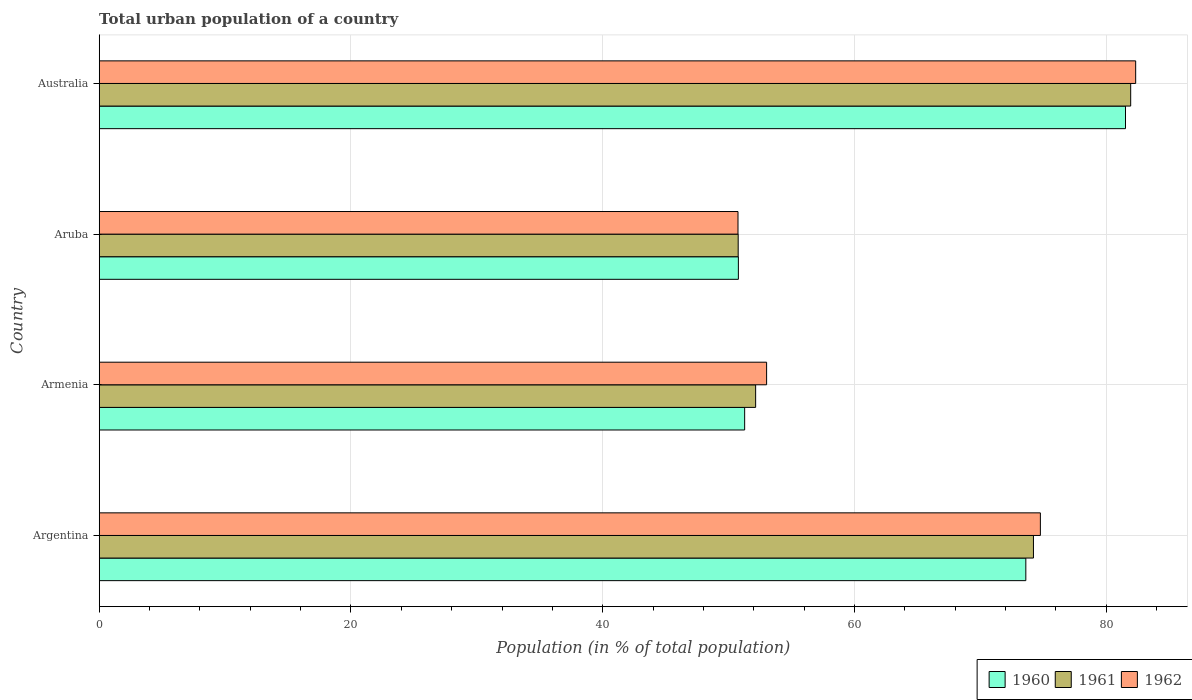Are the number of bars per tick equal to the number of legend labels?
Your response must be concise. Yes. Are the number of bars on each tick of the Y-axis equal?
Your answer should be compact. Yes. How many bars are there on the 2nd tick from the bottom?
Your answer should be very brief. 3. What is the urban population in 1962 in Aruba?
Give a very brief answer. 50.75. Across all countries, what is the maximum urban population in 1962?
Provide a short and direct response. 82.34. Across all countries, what is the minimum urban population in 1962?
Make the answer very short. 50.75. In which country was the urban population in 1962 minimum?
Keep it short and to the point. Aruba. What is the total urban population in 1962 in the graph?
Your answer should be compact. 260.87. What is the difference between the urban population in 1960 in Armenia and that in Australia?
Provide a short and direct response. -30.25. What is the difference between the urban population in 1960 in Argentina and the urban population in 1961 in Australia?
Ensure brevity in your answer.  -8.33. What is the average urban population in 1962 per country?
Your response must be concise. 65.22. What is the difference between the urban population in 1960 and urban population in 1962 in Australia?
Offer a very short reply. -0.81. What is the ratio of the urban population in 1962 in Argentina to that in Australia?
Your answer should be compact. 0.91. Is the difference between the urban population in 1960 in Argentina and Australia greater than the difference between the urban population in 1962 in Argentina and Australia?
Your response must be concise. No. What is the difference between the highest and the second highest urban population in 1961?
Offer a very short reply. 7.72. What is the difference between the highest and the lowest urban population in 1960?
Your response must be concise. 30.75. Is the sum of the urban population in 1961 in Armenia and Aruba greater than the maximum urban population in 1962 across all countries?
Keep it short and to the point. Yes. How many bars are there?
Provide a succinct answer. 12. Does the graph contain grids?
Provide a short and direct response. Yes. Where does the legend appear in the graph?
Give a very brief answer. Bottom right. How many legend labels are there?
Ensure brevity in your answer.  3. What is the title of the graph?
Keep it short and to the point. Total urban population of a country. Does "1992" appear as one of the legend labels in the graph?
Make the answer very short. No. What is the label or title of the X-axis?
Provide a succinct answer. Population (in % of total population). What is the label or title of the Y-axis?
Your response must be concise. Country. What is the Population (in % of total population) in 1960 in Argentina?
Provide a short and direct response. 73.61. What is the Population (in % of total population) in 1961 in Argentina?
Your answer should be very brief. 74.22. What is the Population (in % of total population) in 1962 in Argentina?
Your answer should be very brief. 74.77. What is the Population (in % of total population) in 1960 in Armenia?
Your answer should be very brief. 51.27. What is the Population (in % of total population) in 1961 in Armenia?
Make the answer very short. 52.15. What is the Population (in % of total population) of 1962 in Armenia?
Offer a very short reply. 53.02. What is the Population (in % of total population) of 1960 in Aruba?
Offer a terse response. 50.78. What is the Population (in % of total population) in 1961 in Aruba?
Make the answer very short. 50.76. What is the Population (in % of total population) in 1962 in Aruba?
Make the answer very short. 50.75. What is the Population (in % of total population) in 1960 in Australia?
Your answer should be very brief. 81.53. What is the Population (in % of total population) of 1961 in Australia?
Your response must be concise. 81.94. What is the Population (in % of total population) of 1962 in Australia?
Make the answer very short. 82.34. Across all countries, what is the maximum Population (in % of total population) of 1960?
Your answer should be compact. 81.53. Across all countries, what is the maximum Population (in % of total population) in 1961?
Offer a terse response. 81.94. Across all countries, what is the maximum Population (in % of total population) in 1962?
Provide a short and direct response. 82.34. Across all countries, what is the minimum Population (in % of total population) in 1960?
Give a very brief answer. 50.78. Across all countries, what is the minimum Population (in % of total population) in 1961?
Make the answer very short. 50.76. Across all countries, what is the minimum Population (in % of total population) in 1962?
Your answer should be very brief. 50.75. What is the total Population (in % of total population) in 1960 in the graph?
Provide a short and direct response. 257.19. What is the total Population (in % of total population) of 1961 in the graph?
Provide a succinct answer. 259.07. What is the total Population (in % of total population) in 1962 in the graph?
Give a very brief answer. 260.87. What is the difference between the Population (in % of total population) of 1960 in Argentina and that in Armenia?
Offer a terse response. 22.34. What is the difference between the Population (in % of total population) of 1961 in Argentina and that in Armenia?
Ensure brevity in your answer.  22.07. What is the difference between the Population (in % of total population) in 1962 in Argentina and that in Armenia?
Your response must be concise. 21.75. What is the difference between the Population (in % of total population) of 1960 in Argentina and that in Aruba?
Offer a terse response. 22.84. What is the difference between the Population (in % of total population) of 1961 in Argentina and that in Aruba?
Ensure brevity in your answer.  23.46. What is the difference between the Population (in % of total population) in 1962 in Argentina and that in Aruba?
Provide a succinct answer. 24.02. What is the difference between the Population (in % of total population) of 1960 in Argentina and that in Australia?
Offer a terse response. -7.92. What is the difference between the Population (in % of total population) in 1961 in Argentina and that in Australia?
Your response must be concise. -7.72. What is the difference between the Population (in % of total population) of 1962 in Argentina and that in Australia?
Provide a short and direct response. -7.57. What is the difference between the Population (in % of total population) of 1960 in Armenia and that in Aruba?
Your answer should be compact. 0.5. What is the difference between the Population (in % of total population) of 1961 in Armenia and that in Aruba?
Provide a succinct answer. 1.39. What is the difference between the Population (in % of total population) of 1962 in Armenia and that in Aruba?
Offer a terse response. 2.27. What is the difference between the Population (in % of total population) in 1960 in Armenia and that in Australia?
Your answer should be very brief. -30.25. What is the difference between the Population (in % of total population) of 1961 in Armenia and that in Australia?
Keep it short and to the point. -29.79. What is the difference between the Population (in % of total population) of 1962 in Armenia and that in Australia?
Provide a short and direct response. -29.32. What is the difference between the Population (in % of total population) in 1960 in Aruba and that in Australia?
Offer a very short reply. -30.75. What is the difference between the Population (in % of total population) in 1961 in Aruba and that in Australia?
Your response must be concise. -31.18. What is the difference between the Population (in % of total population) of 1962 in Aruba and that in Australia?
Your response must be concise. -31.59. What is the difference between the Population (in % of total population) of 1960 in Argentina and the Population (in % of total population) of 1961 in Armenia?
Your response must be concise. 21.46. What is the difference between the Population (in % of total population) of 1960 in Argentina and the Population (in % of total population) of 1962 in Armenia?
Ensure brevity in your answer.  20.59. What is the difference between the Population (in % of total population) of 1961 in Argentina and the Population (in % of total population) of 1962 in Armenia?
Give a very brief answer. 21.2. What is the difference between the Population (in % of total population) of 1960 in Argentina and the Population (in % of total population) of 1961 in Aruba?
Keep it short and to the point. 22.85. What is the difference between the Population (in % of total population) in 1960 in Argentina and the Population (in % of total population) in 1962 in Aruba?
Provide a succinct answer. 22.86. What is the difference between the Population (in % of total population) in 1961 in Argentina and the Population (in % of total population) in 1962 in Aruba?
Your answer should be compact. 23.47. What is the difference between the Population (in % of total population) of 1960 in Argentina and the Population (in % of total population) of 1961 in Australia?
Ensure brevity in your answer.  -8.33. What is the difference between the Population (in % of total population) in 1960 in Argentina and the Population (in % of total population) in 1962 in Australia?
Keep it short and to the point. -8.73. What is the difference between the Population (in % of total population) of 1961 in Argentina and the Population (in % of total population) of 1962 in Australia?
Make the answer very short. -8.12. What is the difference between the Population (in % of total population) of 1960 in Armenia and the Population (in % of total population) of 1961 in Aruba?
Offer a very short reply. 0.51. What is the difference between the Population (in % of total population) in 1960 in Armenia and the Population (in % of total population) in 1962 in Aruba?
Offer a very short reply. 0.53. What is the difference between the Population (in % of total population) of 1961 in Armenia and the Population (in % of total population) of 1962 in Aruba?
Give a very brief answer. 1.4. What is the difference between the Population (in % of total population) in 1960 in Armenia and the Population (in % of total population) in 1961 in Australia?
Your response must be concise. -30.67. What is the difference between the Population (in % of total population) in 1960 in Armenia and the Population (in % of total population) in 1962 in Australia?
Offer a terse response. -31.06. What is the difference between the Population (in % of total population) in 1961 in Armenia and the Population (in % of total population) in 1962 in Australia?
Provide a short and direct response. -30.19. What is the difference between the Population (in % of total population) in 1960 in Aruba and the Population (in % of total population) in 1961 in Australia?
Ensure brevity in your answer.  -31.16. What is the difference between the Population (in % of total population) of 1960 in Aruba and the Population (in % of total population) of 1962 in Australia?
Provide a short and direct response. -31.56. What is the difference between the Population (in % of total population) of 1961 in Aruba and the Population (in % of total population) of 1962 in Australia?
Offer a very short reply. -31.58. What is the average Population (in % of total population) of 1960 per country?
Make the answer very short. 64.3. What is the average Population (in % of total population) in 1961 per country?
Keep it short and to the point. 64.77. What is the average Population (in % of total population) in 1962 per country?
Your answer should be very brief. 65.22. What is the difference between the Population (in % of total population) of 1960 and Population (in % of total population) of 1961 in Argentina?
Your answer should be very brief. -0.61. What is the difference between the Population (in % of total population) in 1960 and Population (in % of total population) in 1962 in Argentina?
Provide a short and direct response. -1.16. What is the difference between the Population (in % of total population) in 1961 and Population (in % of total population) in 1962 in Argentina?
Your response must be concise. -0.55. What is the difference between the Population (in % of total population) in 1960 and Population (in % of total population) in 1961 in Armenia?
Ensure brevity in your answer.  -0.87. What is the difference between the Population (in % of total population) of 1960 and Population (in % of total population) of 1962 in Armenia?
Your answer should be very brief. -1.74. What is the difference between the Population (in % of total population) in 1961 and Population (in % of total population) in 1962 in Armenia?
Offer a terse response. -0.87. What is the difference between the Population (in % of total population) of 1960 and Population (in % of total population) of 1961 in Aruba?
Your answer should be very brief. 0.01. What is the difference between the Population (in % of total population) in 1961 and Population (in % of total population) in 1962 in Aruba?
Your answer should be very brief. 0.01. What is the difference between the Population (in % of total population) in 1960 and Population (in % of total population) in 1961 in Australia?
Offer a very short reply. -0.41. What is the difference between the Population (in % of total population) of 1960 and Population (in % of total population) of 1962 in Australia?
Keep it short and to the point. -0.81. What is the difference between the Population (in % of total population) of 1961 and Population (in % of total population) of 1962 in Australia?
Keep it short and to the point. -0.4. What is the ratio of the Population (in % of total population) of 1960 in Argentina to that in Armenia?
Make the answer very short. 1.44. What is the ratio of the Population (in % of total population) in 1961 in Argentina to that in Armenia?
Offer a very short reply. 1.42. What is the ratio of the Population (in % of total population) in 1962 in Argentina to that in Armenia?
Offer a terse response. 1.41. What is the ratio of the Population (in % of total population) of 1960 in Argentina to that in Aruba?
Offer a terse response. 1.45. What is the ratio of the Population (in % of total population) in 1961 in Argentina to that in Aruba?
Your response must be concise. 1.46. What is the ratio of the Population (in % of total population) of 1962 in Argentina to that in Aruba?
Ensure brevity in your answer.  1.47. What is the ratio of the Population (in % of total population) in 1960 in Argentina to that in Australia?
Ensure brevity in your answer.  0.9. What is the ratio of the Population (in % of total population) in 1961 in Argentina to that in Australia?
Provide a succinct answer. 0.91. What is the ratio of the Population (in % of total population) of 1962 in Argentina to that in Australia?
Provide a succinct answer. 0.91. What is the ratio of the Population (in % of total population) in 1960 in Armenia to that in Aruba?
Keep it short and to the point. 1.01. What is the ratio of the Population (in % of total population) in 1961 in Armenia to that in Aruba?
Your response must be concise. 1.03. What is the ratio of the Population (in % of total population) of 1962 in Armenia to that in Aruba?
Give a very brief answer. 1.04. What is the ratio of the Population (in % of total population) in 1960 in Armenia to that in Australia?
Provide a short and direct response. 0.63. What is the ratio of the Population (in % of total population) of 1961 in Armenia to that in Australia?
Keep it short and to the point. 0.64. What is the ratio of the Population (in % of total population) of 1962 in Armenia to that in Australia?
Offer a very short reply. 0.64. What is the ratio of the Population (in % of total population) of 1960 in Aruba to that in Australia?
Your answer should be compact. 0.62. What is the ratio of the Population (in % of total population) of 1961 in Aruba to that in Australia?
Make the answer very short. 0.62. What is the ratio of the Population (in % of total population) in 1962 in Aruba to that in Australia?
Your answer should be compact. 0.62. What is the difference between the highest and the second highest Population (in % of total population) in 1960?
Provide a short and direct response. 7.92. What is the difference between the highest and the second highest Population (in % of total population) of 1961?
Offer a very short reply. 7.72. What is the difference between the highest and the second highest Population (in % of total population) of 1962?
Your answer should be very brief. 7.57. What is the difference between the highest and the lowest Population (in % of total population) of 1960?
Your answer should be very brief. 30.75. What is the difference between the highest and the lowest Population (in % of total population) of 1961?
Your answer should be very brief. 31.18. What is the difference between the highest and the lowest Population (in % of total population) in 1962?
Ensure brevity in your answer.  31.59. 